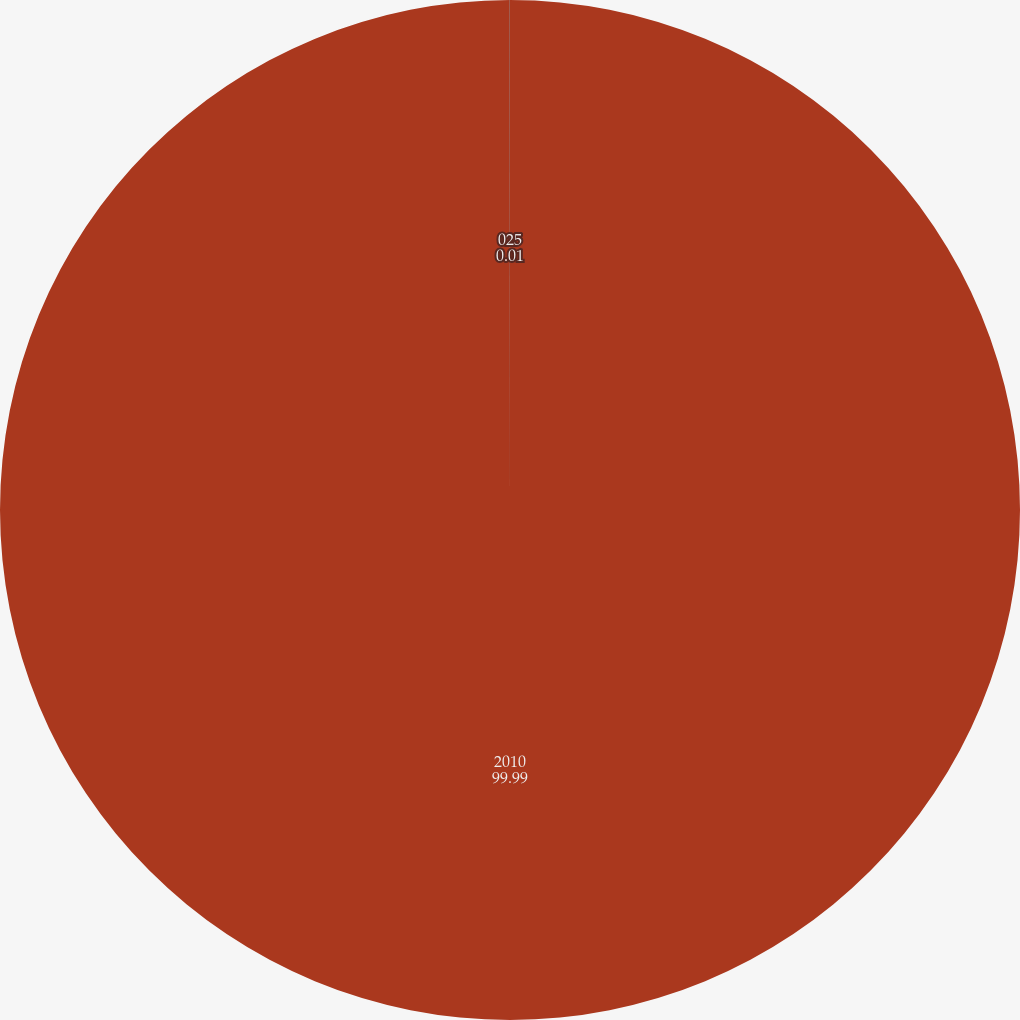<chart> <loc_0><loc_0><loc_500><loc_500><pie_chart><fcel>2010<fcel>025<nl><fcel>99.99%<fcel>0.01%<nl></chart> 